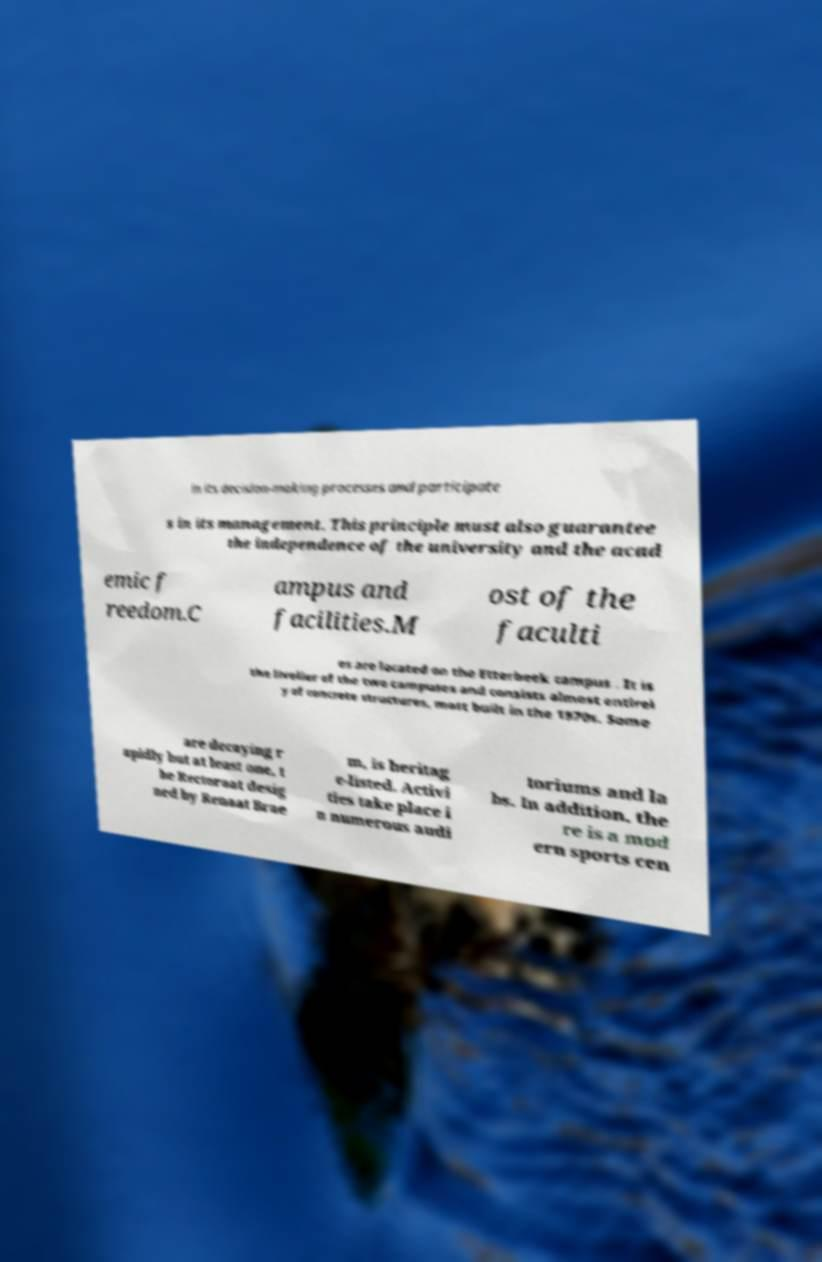I need the written content from this picture converted into text. Can you do that? in its decision-making processes and participate s in its management. This principle must also guarantee the independence of the university and the acad emic f reedom.C ampus and facilities.M ost of the faculti es are located on the Etterbeek campus . It is the livelier of the two campuses and consists almost entirel y of concrete structures, most built in the 1970s. Some are decaying r apidly but at least one, t he Rectoraat desig ned by Renaat Brae m, is heritag e-listed. Activi ties take place i n numerous audi toriums and la bs. In addition, the re is a mod ern sports cen 